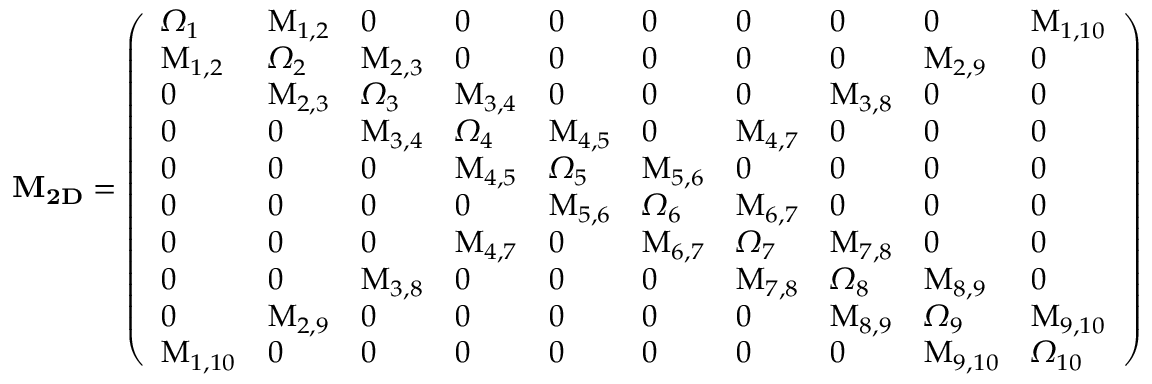<formula> <loc_0><loc_0><loc_500><loc_500>M _ { 2 D } = \left ( \begin{array} { l l l l l l l l l l } { \Omega _ { 1 } } & { M _ { 1 , 2 } } & { 0 } & { 0 } & { 0 } & { 0 } & { 0 } & { 0 } & { 0 } & { M _ { 1 , 1 0 } } \\ { M _ { 1 , 2 } } & { \Omega _ { 2 } } & { M _ { 2 , 3 } } & { 0 } & { 0 } & { 0 } & { 0 } & { 0 } & { M _ { 2 , 9 } } & { 0 } \\ { 0 } & { M _ { 2 , 3 } } & { \Omega _ { 3 } } & { M _ { 3 , 4 } } & { 0 } & { 0 } & { 0 } & { M _ { 3 , 8 } } & { 0 } & { 0 } \\ { 0 } & { 0 } & { M _ { 3 , 4 } } & { \Omega _ { 4 } } & { M _ { 4 , 5 } } & { 0 } & { M _ { 4 , 7 } } & { 0 } & { 0 } & { 0 } \\ { 0 } & { 0 } & { 0 } & { M _ { 4 , 5 } } & { \Omega _ { 5 } } & { M _ { 5 , 6 } } & { 0 } & { 0 } & { 0 } & { 0 } \\ { 0 } & { 0 } & { 0 } & { 0 } & { M _ { 5 , 6 } } & { \Omega _ { 6 } } & { M _ { 6 , 7 } } & { 0 } & { 0 } & { 0 } \\ { 0 } & { 0 } & { 0 } & { M _ { 4 , 7 } } & { 0 } & { M _ { 6 , 7 } } & { \Omega _ { 7 } } & { M _ { 7 , 8 } } & { 0 } & { 0 } \\ { 0 } & { 0 } & { M _ { 3 , 8 } } & { 0 } & { 0 } & { 0 } & { M _ { 7 , 8 } } & { \Omega _ { 8 } } & { M _ { 8 , 9 } } & { 0 } \\ { 0 } & { M _ { 2 , 9 } } & { 0 } & { 0 } & { 0 } & { 0 } & { 0 } & { M _ { 8 , 9 } } & { \Omega _ { 9 } } & { M _ { 9 , 1 0 } } \\ { M _ { 1 , 1 0 } } & { 0 } & { 0 } & { 0 } & { 0 } & { 0 } & { 0 } & { 0 } & { M _ { 9 , 1 0 } } & { \Omega _ { 1 0 } } \end{array} \right )</formula> 